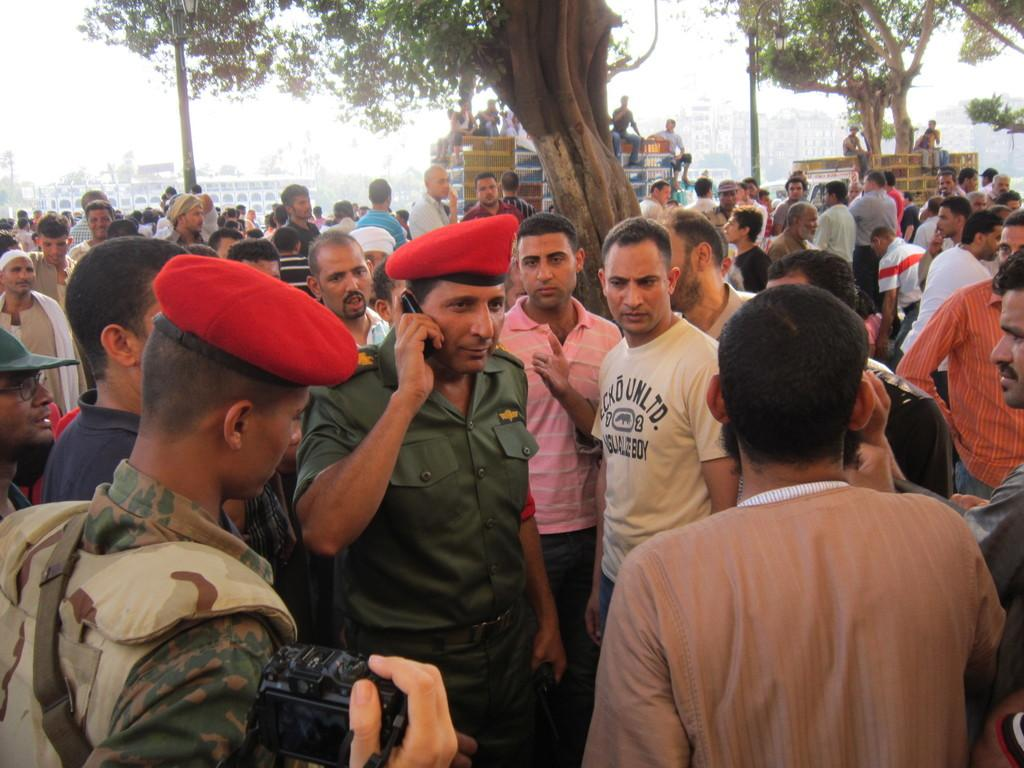How many people are in the image? There is a group of people in the image. What are some of the people wearing? Some of the people are wearing army uniforms. What can be seen in the background of the image? There are trees and buildings in the background of the image. What type of marble is being used to make the jelly in the image? There is no marble or jelly present in the image. 